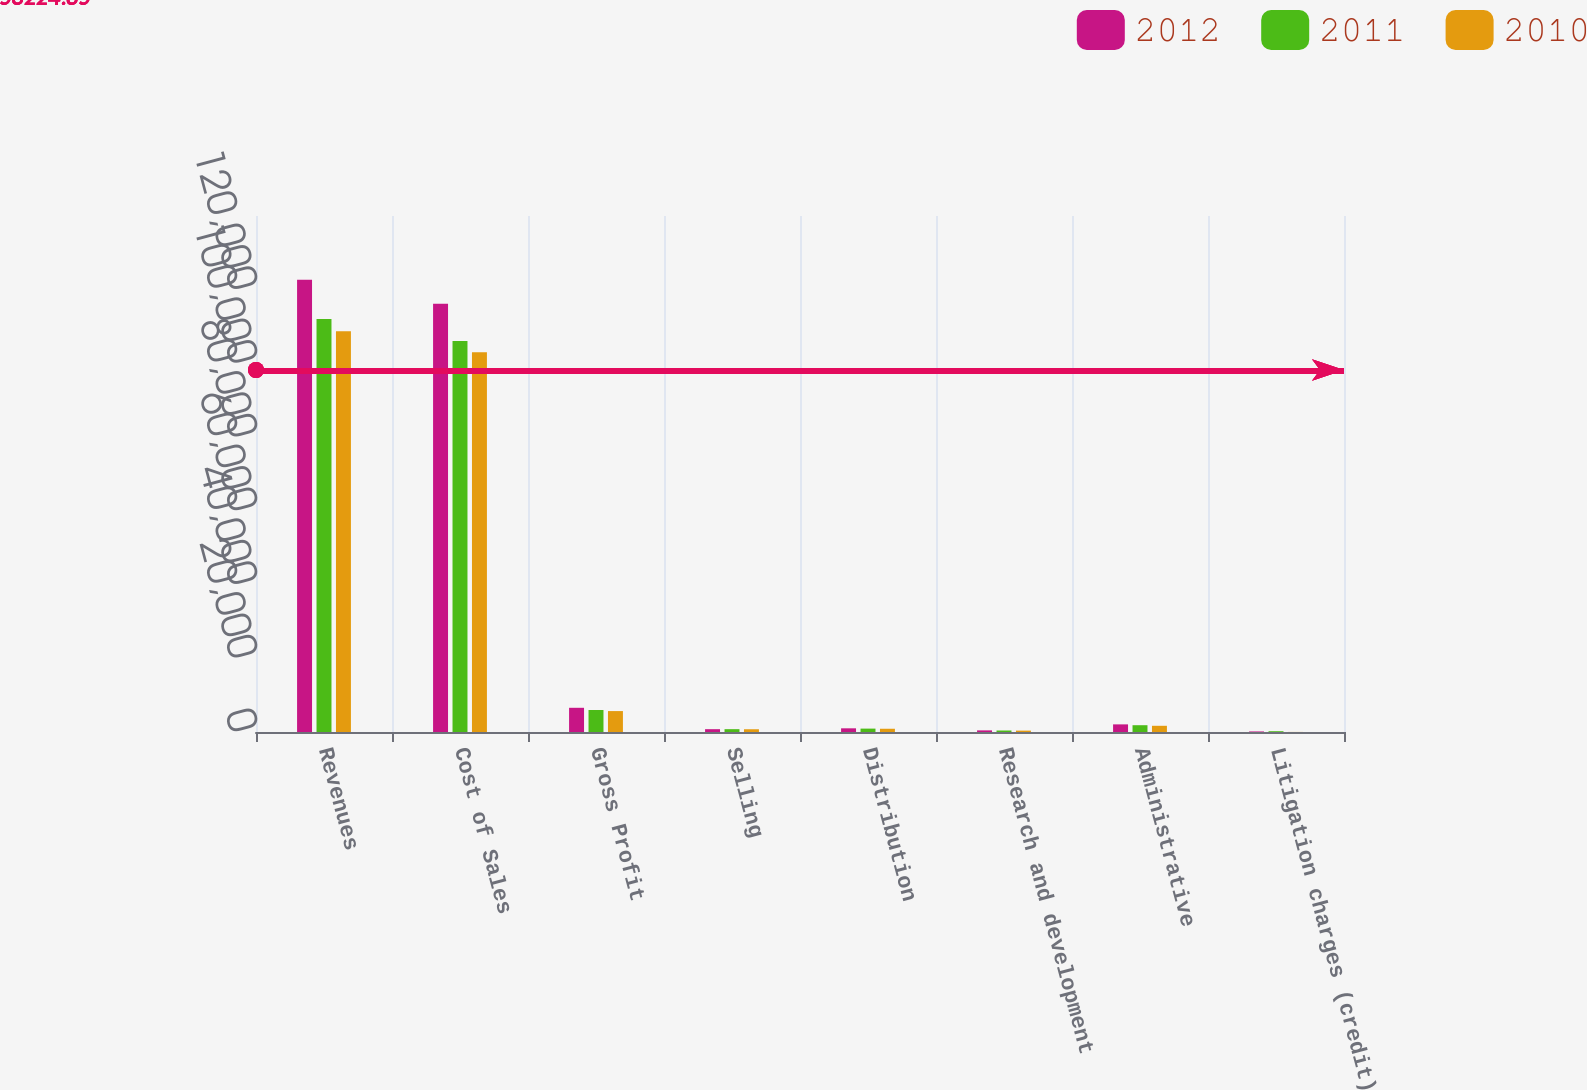Convert chart to OTSL. <chart><loc_0><loc_0><loc_500><loc_500><stacked_bar_chart><ecel><fcel>Revenues<fcel>Cost of Sales<fcel>Gross Profit<fcel>Selling<fcel>Distribution<fcel>Research and development<fcel>Administrative<fcel>Litigation charges (credit)<nl><fcel>2012<fcel>122734<fcel>116167<fcel>6567<fcel>764<fcel>997<fcel>440<fcel>2068<fcel>149<nl><fcel>2011<fcel>112084<fcel>106114<fcel>5970<fcel>767<fcel>920<fcel>407<fcel>1842<fcel>213<nl><fcel>2010<fcel>108702<fcel>103026<fcel>5676<fcel>746<fcel>882<fcel>376<fcel>1684<fcel>20<nl></chart> 